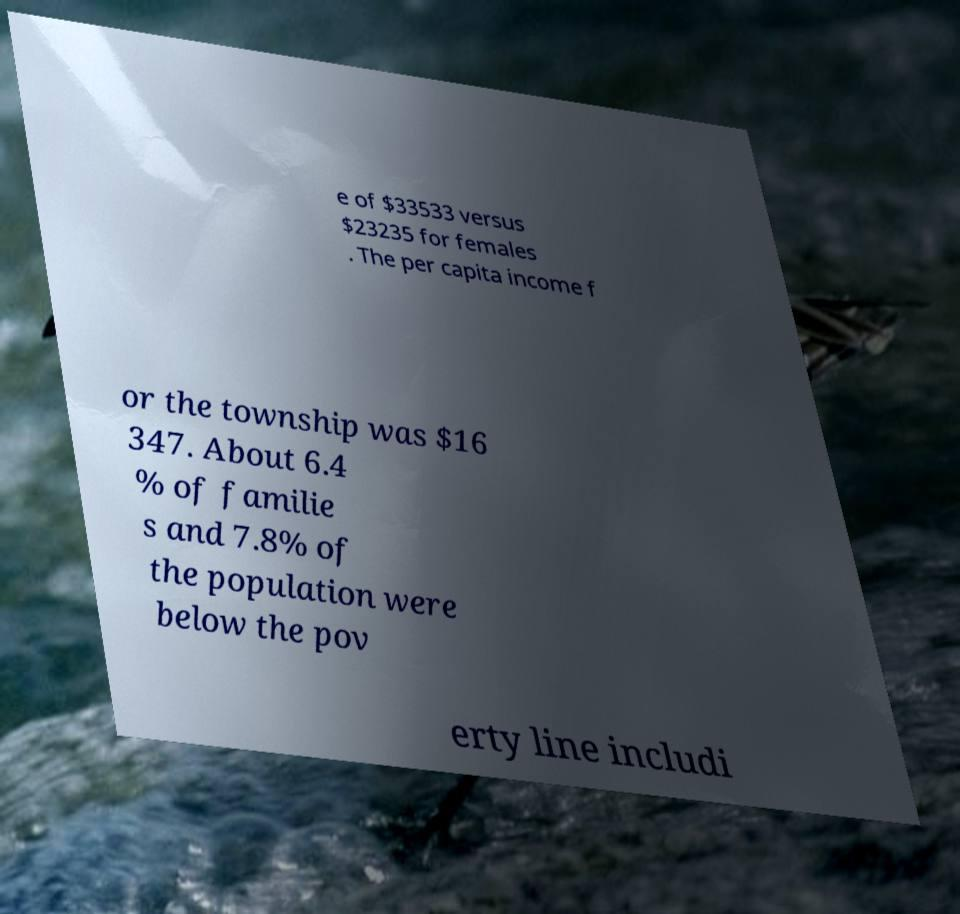I need the written content from this picture converted into text. Can you do that? e of $33533 versus $23235 for females . The per capita income f or the township was $16 347. About 6.4 % of familie s and 7.8% of the population were below the pov erty line includi 